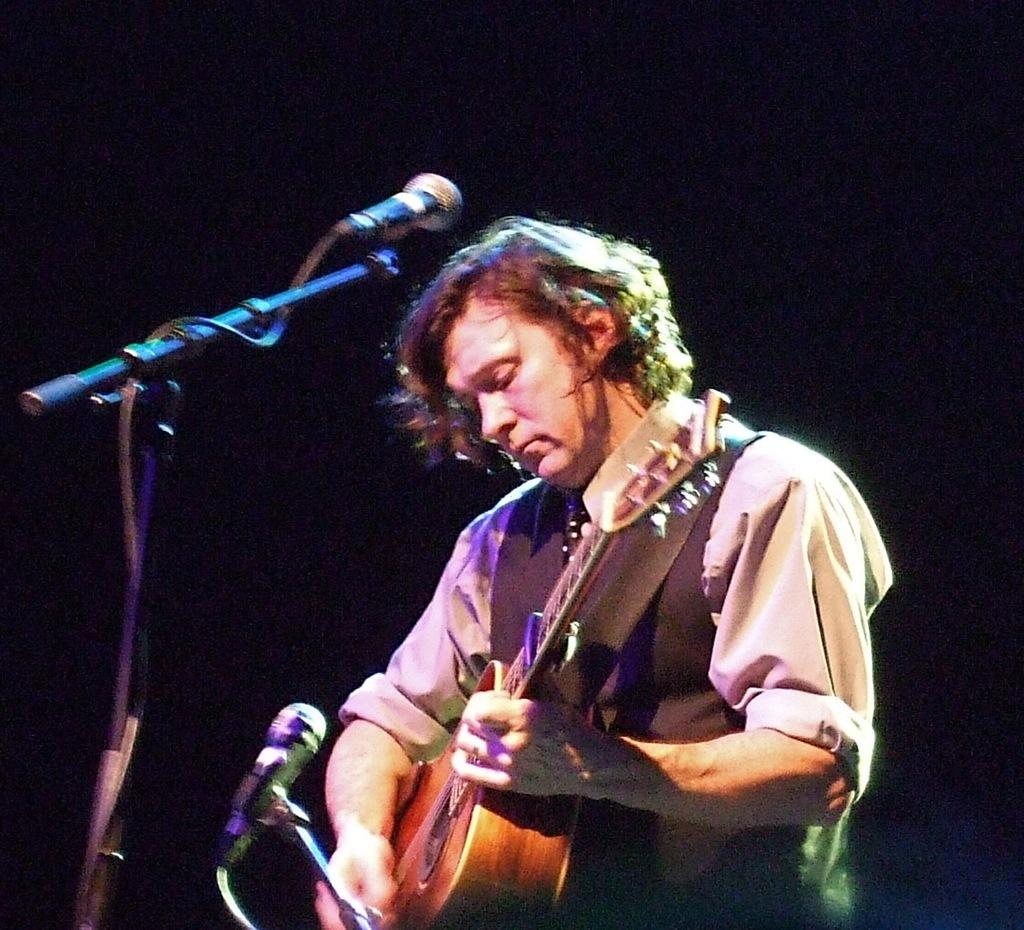What is the man in the image doing? The man is playing a guitar in the image. What object is present in the image that is typically used for amplifying sound? There is a microphone in the image. How is the microphone positioned in the image? The microphone has a mic holder in the image. What type of pencil can be seen being used to mark the guitar in the image? There is no pencil or marking activity present in the image; the man is simply playing the guitar. 